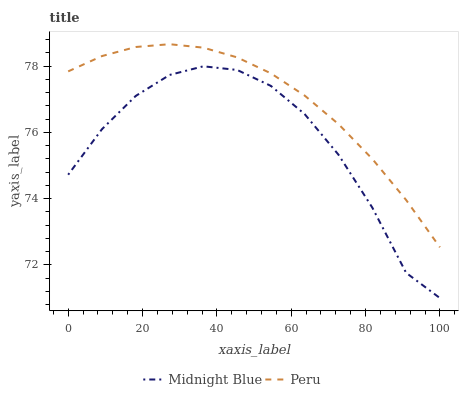Does Midnight Blue have the minimum area under the curve?
Answer yes or no. Yes. Does Peru have the maximum area under the curve?
Answer yes or no. Yes. Does Peru have the minimum area under the curve?
Answer yes or no. No. Is Peru the smoothest?
Answer yes or no. Yes. Is Midnight Blue the roughest?
Answer yes or no. Yes. Is Peru the roughest?
Answer yes or no. No. Does Midnight Blue have the lowest value?
Answer yes or no. Yes. Does Peru have the lowest value?
Answer yes or no. No. Does Peru have the highest value?
Answer yes or no. Yes. Is Midnight Blue less than Peru?
Answer yes or no. Yes. Is Peru greater than Midnight Blue?
Answer yes or no. Yes. Does Midnight Blue intersect Peru?
Answer yes or no. No. 